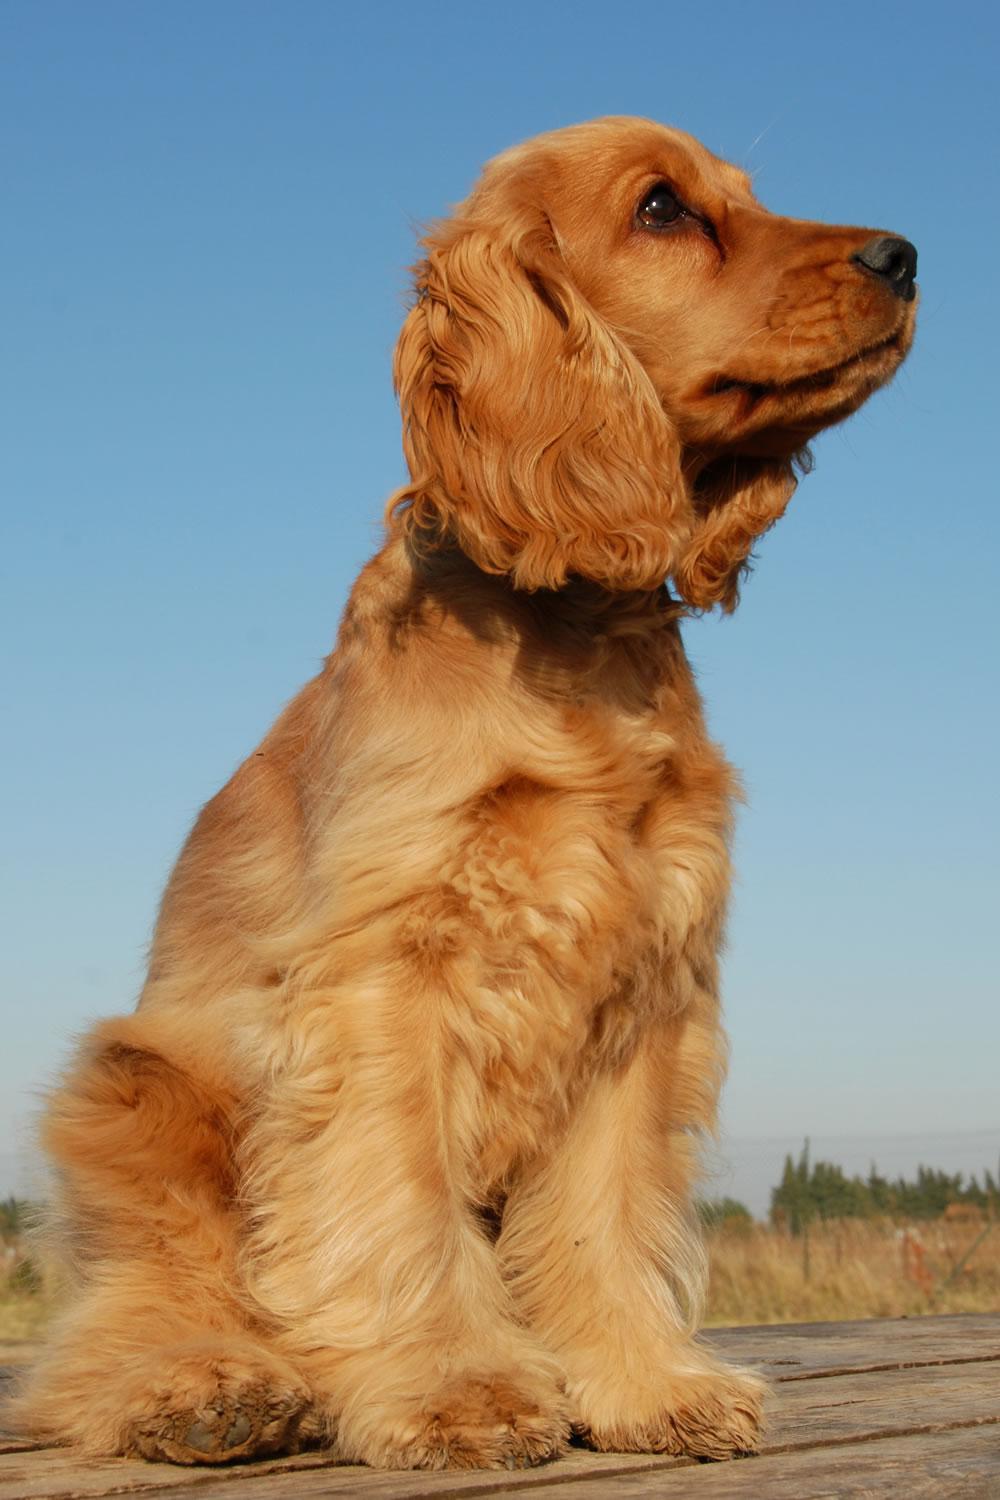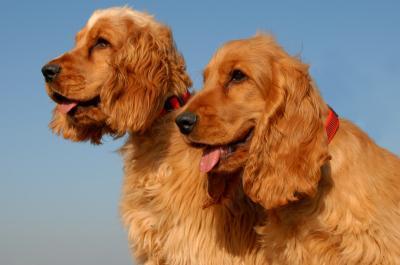The first image is the image on the left, the second image is the image on the right. Assess this claim about the two images: "There are three dogs". Correct or not? Answer yes or no. Yes. 